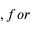<formula> <loc_0><loc_0><loc_500><loc_500>, f o r</formula> 